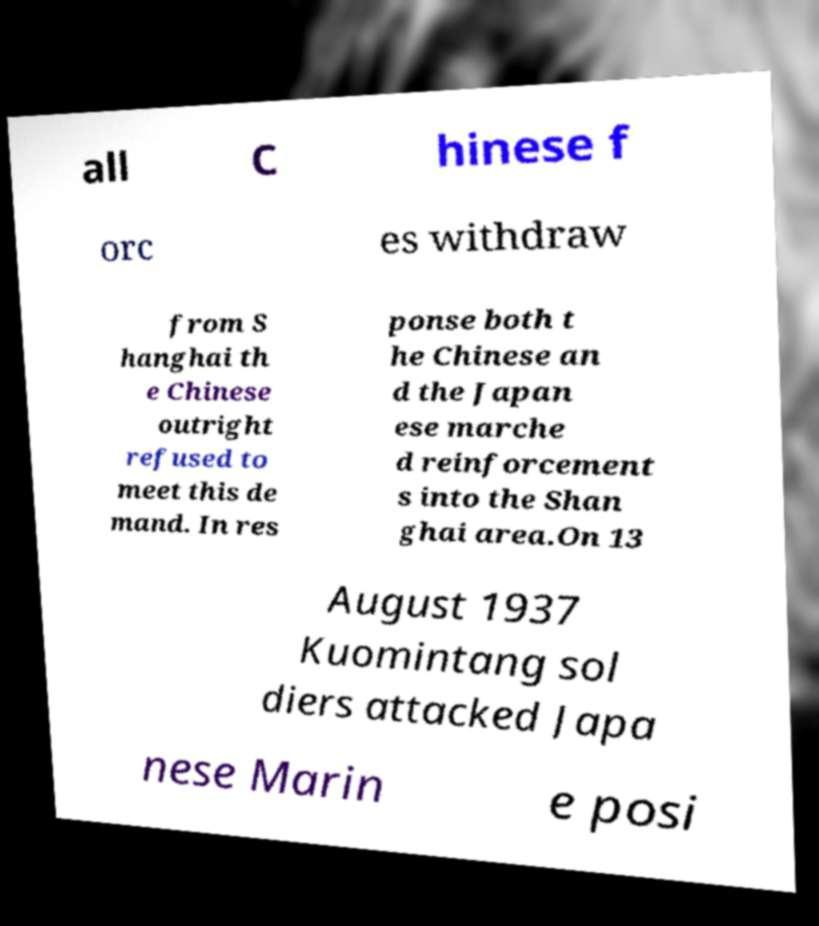Could you extract and type out the text from this image? all C hinese f orc es withdraw from S hanghai th e Chinese outright refused to meet this de mand. In res ponse both t he Chinese an d the Japan ese marche d reinforcement s into the Shan ghai area.On 13 August 1937 Kuomintang sol diers attacked Japa nese Marin e posi 